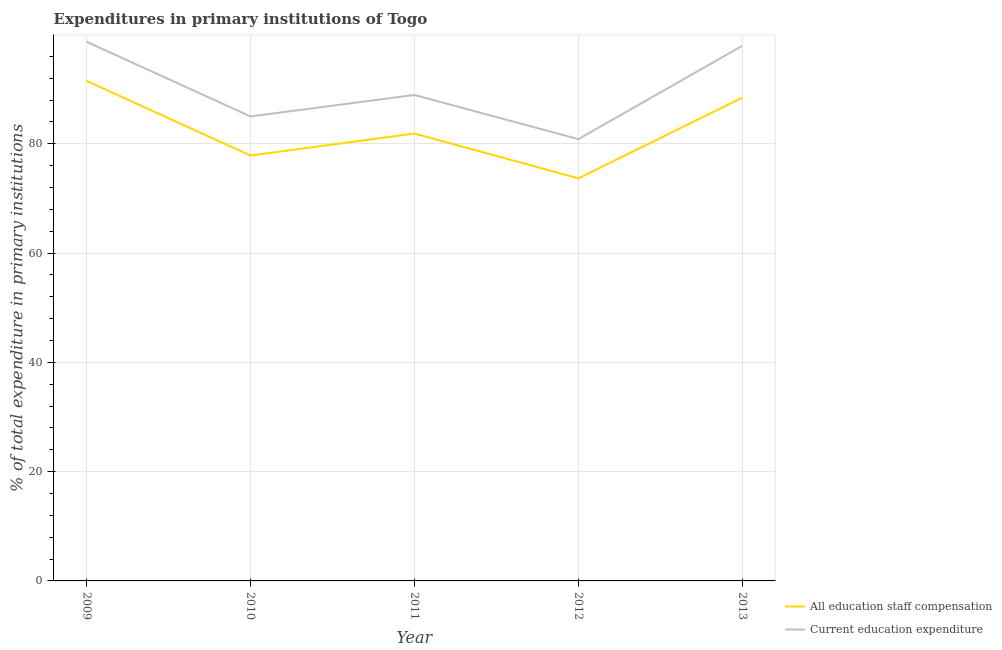How many different coloured lines are there?
Your answer should be compact. 2. Does the line corresponding to expenditure in staff compensation intersect with the line corresponding to expenditure in education?
Provide a succinct answer. No. What is the expenditure in staff compensation in 2009?
Give a very brief answer. 91.51. Across all years, what is the maximum expenditure in staff compensation?
Your answer should be compact. 91.51. Across all years, what is the minimum expenditure in education?
Give a very brief answer. 80.84. In which year was the expenditure in education minimum?
Keep it short and to the point. 2012. What is the total expenditure in education in the graph?
Offer a terse response. 451.37. What is the difference between the expenditure in education in 2011 and that in 2012?
Offer a terse response. 8.08. What is the difference between the expenditure in education in 2012 and the expenditure in staff compensation in 2009?
Give a very brief answer. -10.67. What is the average expenditure in staff compensation per year?
Keep it short and to the point. 82.67. In the year 2009, what is the difference between the expenditure in staff compensation and expenditure in education?
Give a very brief answer. -7.16. In how many years, is the expenditure in staff compensation greater than 28 %?
Provide a succinct answer. 5. What is the ratio of the expenditure in education in 2009 to that in 2013?
Provide a succinct answer. 1.01. Is the expenditure in education in 2009 less than that in 2010?
Your response must be concise. No. What is the difference between the highest and the second highest expenditure in education?
Provide a succinct answer. 0.74. What is the difference between the highest and the lowest expenditure in staff compensation?
Your response must be concise. 17.84. How many lines are there?
Your answer should be compact. 2. Are the values on the major ticks of Y-axis written in scientific E-notation?
Offer a very short reply. No. Does the graph contain grids?
Your response must be concise. Yes. Where does the legend appear in the graph?
Your answer should be compact. Bottom right. How many legend labels are there?
Ensure brevity in your answer.  2. What is the title of the graph?
Offer a very short reply. Expenditures in primary institutions of Togo. What is the label or title of the X-axis?
Your answer should be very brief. Year. What is the label or title of the Y-axis?
Make the answer very short. % of total expenditure in primary institutions. What is the % of total expenditure in primary institutions of All education staff compensation in 2009?
Your response must be concise. 91.51. What is the % of total expenditure in primary institutions of Current education expenditure in 2009?
Offer a very short reply. 98.67. What is the % of total expenditure in primary institutions in All education staff compensation in 2010?
Keep it short and to the point. 77.85. What is the % of total expenditure in primary institutions of Current education expenditure in 2010?
Make the answer very short. 85. What is the % of total expenditure in primary institutions of All education staff compensation in 2011?
Offer a terse response. 81.87. What is the % of total expenditure in primary institutions of Current education expenditure in 2011?
Provide a short and direct response. 88.93. What is the % of total expenditure in primary institutions of All education staff compensation in 2012?
Offer a terse response. 73.67. What is the % of total expenditure in primary institutions of Current education expenditure in 2012?
Your answer should be very brief. 80.84. What is the % of total expenditure in primary institutions of All education staff compensation in 2013?
Offer a very short reply. 88.44. What is the % of total expenditure in primary institutions of Current education expenditure in 2013?
Provide a succinct answer. 97.93. Across all years, what is the maximum % of total expenditure in primary institutions in All education staff compensation?
Your answer should be very brief. 91.51. Across all years, what is the maximum % of total expenditure in primary institutions in Current education expenditure?
Provide a succinct answer. 98.67. Across all years, what is the minimum % of total expenditure in primary institutions of All education staff compensation?
Provide a succinct answer. 73.67. Across all years, what is the minimum % of total expenditure in primary institutions of Current education expenditure?
Provide a succinct answer. 80.84. What is the total % of total expenditure in primary institutions in All education staff compensation in the graph?
Keep it short and to the point. 413.33. What is the total % of total expenditure in primary institutions in Current education expenditure in the graph?
Provide a succinct answer. 451.37. What is the difference between the % of total expenditure in primary institutions in All education staff compensation in 2009 and that in 2010?
Give a very brief answer. 13.66. What is the difference between the % of total expenditure in primary institutions in Current education expenditure in 2009 and that in 2010?
Offer a very short reply. 13.67. What is the difference between the % of total expenditure in primary institutions in All education staff compensation in 2009 and that in 2011?
Make the answer very short. 9.64. What is the difference between the % of total expenditure in primary institutions in Current education expenditure in 2009 and that in 2011?
Make the answer very short. 9.74. What is the difference between the % of total expenditure in primary institutions in All education staff compensation in 2009 and that in 2012?
Give a very brief answer. 17.84. What is the difference between the % of total expenditure in primary institutions in Current education expenditure in 2009 and that in 2012?
Offer a very short reply. 17.83. What is the difference between the % of total expenditure in primary institutions in All education staff compensation in 2009 and that in 2013?
Ensure brevity in your answer.  3.07. What is the difference between the % of total expenditure in primary institutions of Current education expenditure in 2009 and that in 2013?
Offer a terse response. 0.74. What is the difference between the % of total expenditure in primary institutions of All education staff compensation in 2010 and that in 2011?
Make the answer very short. -4.02. What is the difference between the % of total expenditure in primary institutions of Current education expenditure in 2010 and that in 2011?
Make the answer very short. -3.93. What is the difference between the % of total expenditure in primary institutions of All education staff compensation in 2010 and that in 2012?
Offer a terse response. 4.18. What is the difference between the % of total expenditure in primary institutions of Current education expenditure in 2010 and that in 2012?
Keep it short and to the point. 4.15. What is the difference between the % of total expenditure in primary institutions in All education staff compensation in 2010 and that in 2013?
Your response must be concise. -10.59. What is the difference between the % of total expenditure in primary institutions of Current education expenditure in 2010 and that in 2013?
Ensure brevity in your answer.  -12.93. What is the difference between the % of total expenditure in primary institutions of All education staff compensation in 2011 and that in 2012?
Ensure brevity in your answer.  8.2. What is the difference between the % of total expenditure in primary institutions of Current education expenditure in 2011 and that in 2012?
Offer a very short reply. 8.08. What is the difference between the % of total expenditure in primary institutions of All education staff compensation in 2011 and that in 2013?
Provide a succinct answer. -6.57. What is the difference between the % of total expenditure in primary institutions of Current education expenditure in 2011 and that in 2013?
Your answer should be compact. -9.01. What is the difference between the % of total expenditure in primary institutions of All education staff compensation in 2012 and that in 2013?
Give a very brief answer. -14.77. What is the difference between the % of total expenditure in primary institutions of Current education expenditure in 2012 and that in 2013?
Your answer should be very brief. -17.09. What is the difference between the % of total expenditure in primary institutions in All education staff compensation in 2009 and the % of total expenditure in primary institutions in Current education expenditure in 2010?
Offer a terse response. 6.51. What is the difference between the % of total expenditure in primary institutions in All education staff compensation in 2009 and the % of total expenditure in primary institutions in Current education expenditure in 2011?
Your answer should be compact. 2.58. What is the difference between the % of total expenditure in primary institutions of All education staff compensation in 2009 and the % of total expenditure in primary institutions of Current education expenditure in 2012?
Make the answer very short. 10.67. What is the difference between the % of total expenditure in primary institutions in All education staff compensation in 2009 and the % of total expenditure in primary institutions in Current education expenditure in 2013?
Ensure brevity in your answer.  -6.42. What is the difference between the % of total expenditure in primary institutions in All education staff compensation in 2010 and the % of total expenditure in primary institutions in Current education expenditure in 2011?
Give a very brief answer. -11.08. What is the difference between the % of total expenditure in primary institutions in All education staff compensation in 2010 and the % of total expenditure in primary institutions in Current education expenditure in 2012?
Offer a terse response. -3. What is the difference between the % of total expenditure in primary institutions in All education staff compensation in 2010 and the % of total expenditure in primary institutions in Current education expenditure in 2013?
Provide a succinct answer. -20.09. What is the difference between the % of total expenditure in primary institutions of All education staff compensation in 2011 and the % of total expenditure in primary institutions of Current education expenditure in 2012?
Offer a terse response. 1.02. What is the difference between the % of total expenditure in primary institutions in All education staff compensation in 2011 and the % of total expenditure in primary institutions in Current education expenditure in 2013?
Provide a succinct answer. -16.07. What is the difference between the % of total expenditure in primary institutions of All education staff compensation in 2012 and the % of total expenditure in primary institutions of Current education expenditure in 2013?
Provide a short and direct response. -24.26. What is the average % of total expenditure in primary institutions of All education staff compensation per year?
Provide a short and direct response. 82.67. What is the average % of total expenditure in primary institutions of Current education expenditure per year?
Offer a very short reply. 90.27. In the year 2009, what is the difference between the % of total expenditure in primary institutions in All education staff compensation and % of total expenditure in primary institutions in Current education expenditure?
Ensure brevity in your answer.  -7.16. In the year 2010, what is the difference between the % of total expenditure in primary institutions of All education staff compensation and % of total expenditure in primary institutions of Current education expenditure?
Your answer should be compact. -7.15. In the year 2011, what is the difference between the % of total expenditure in primary institutions in All education staff compensation and % of total expenditure in primary institutions in Current education expenditure?
Offer a very short reply. -7.06. In the year 2012, what is the difference between the % of total expenditure in primary institutions of All education staff compensation and % of total expenditure in primary institutions of Current education expenditure?
Provide a succinct answer. -7.18. In the year 2013, what is the difference between the % of total expenditure in primary institutions in All education staff compensation and % of total expenditure in primary institutions in Current education expenditure?
Your response must be concise. -9.49. What is the ratio of the % of total expenditure in primary institutions of All education staff compensation in 2009 to that in 2010?
Your answer should be compact. 1.18. What is the ratio of the % of total expenditure in primary institutions of Current education expenditure in 2009 to that in 2010?
Your answer should be compact. 1.16. What is the ratio of the % of total expenditure in primary institutions in All education staff compensation in 2009 to that in 2011?
Offer a very short reply. 1.12. What is the ratio of the % of total expenditure in primary institutions of Current education expenditure in 2009 to that in 2011?
Make the answer very short. 1.11. What is the ratio of the % of total expenditure in primary institutions of All education staff compensation in 2009 to that in 2012?
Provide a succinct answer. 1.24. What is the ratio of the % of total expenditure in primary institutions in Current education expenditure in 2009 to that in 2012?
Keep it short and to the point. 1.22. What is the ratio of the % of total expenditure in primary institutions in All education staff compensation in 2009 to that in 2013?
Provide a short and direct response. 1.03. What is the ratio of the % of total expenditure in primary institutions of Current education expenditure in 2009 to that in 2013?
Your answer should be compact. 1.01. What is the ratio of the % of total expenditure in primary institutions of All education staff compensation in 2010 to that in 2011?
Your response must be concise. 0.95. What is the ratio of the % of total expenditure in primary institutions in Current education expenditure in 2010 to that in 2011?
Provide a short and direct response. 0.96. What is the ratio of the % of total expenditure in primary institutions of All education staff compensation in 2010 to that in 2012?
Your answer should be compact. 1.06. What is the ratio of the % of total expenditure in primary institutions in Current education expenditure in 2010 to that in 2012?
Your response must be concise. 1.05. What is the ratio of the % of total expenditure in primary institutions in All education staff compensation in 2010 to that in 2013?
Offer a very short reply. 0.88. What is the ratio of the % of total expenditure in primary institutions in Current education expenditure in 2010 to that in 2013?
Your answer should be very brief. 0.87. What is the ratio of the % of total expenditure in primary institutions in All education staff compensation in 2011 to that in 2012?
Ensure brevity in your answer.  1.11. What is the ratio of the % of total expenditure in primary institutions in Current education expenditure in 2011 to that in 2012?
Give a very brief answer. 1.1. What is the ratio of the % of total expenditure in primary institutions in All education staff compensation in 2011 to that in 2013?
Your answer should be compact. 0.93. What is the ratio of the % of total expenditure in primary institutions in Current education expenditure in 2011 to that in 2013?
Provide a short and direct response. 0.91. What is the ratio of the % of total expenditure in primary institutions of All education staff compensation in 2012 to that in 2013?
Keep it short and to the point. 0.83. What is the ratio of the % of total expenditure in primary institutions of Current education expenditure in 2012 to that in 2013?
Ensure brevity in your answer.  0.83. What is the difference between the highest and the second highest % of total expenditure in primary institutions of All education staff compensation?
Your answer should be very brief. 3.07. What is the difference between the highest and the second highest % of total expenditure in primary institutions in Current education expenditure?
Ensure brevity in your answer.  0.74. What is the difference between the highest and the lowest % of total expenditure in primary institutions of All education staff compensation?
Offer a very short reply. 17.84. What is the difference between the highest and the lowest % of total expenditure in primary institutions in Current education expenditure?
Your response must be concise. 17.83. 